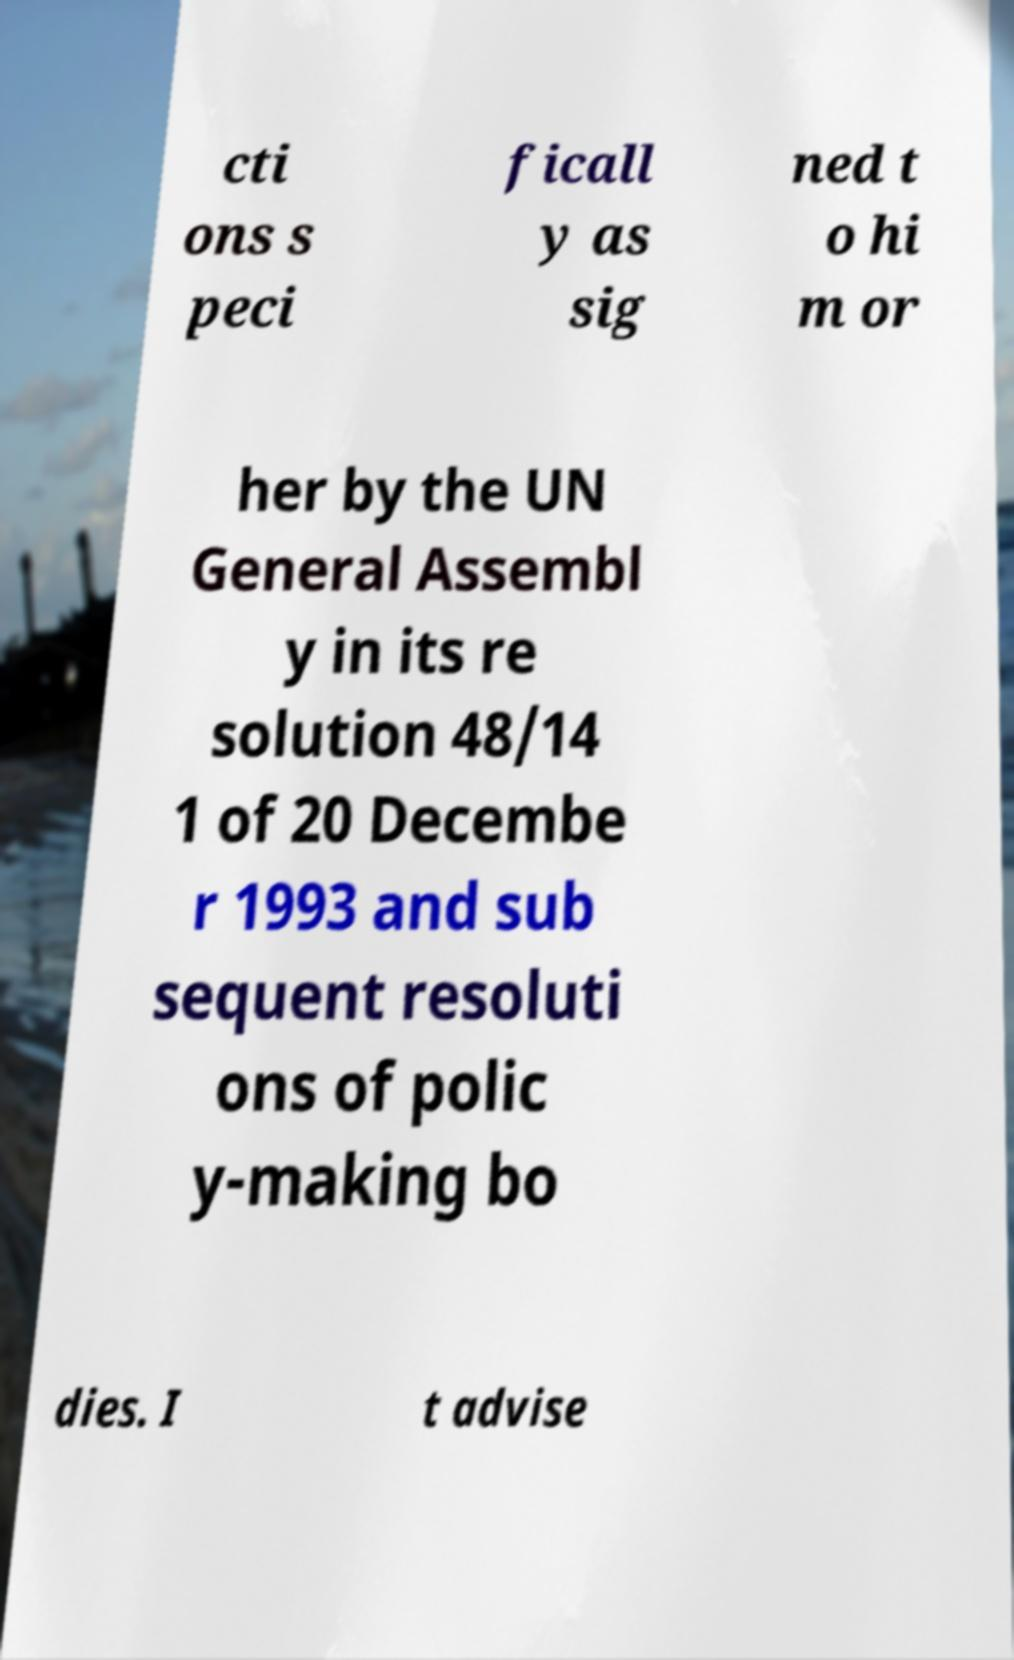Please read and relay the text visible in this image. What does it say? cti ons s peci ficall y as sig ned t o hi m or her by the UN General Assembl y in its re solution 48/14 1 of 20 Decembe r 1993 and sub sequent resoluti ons of polic y-making bo dies. I t advise 